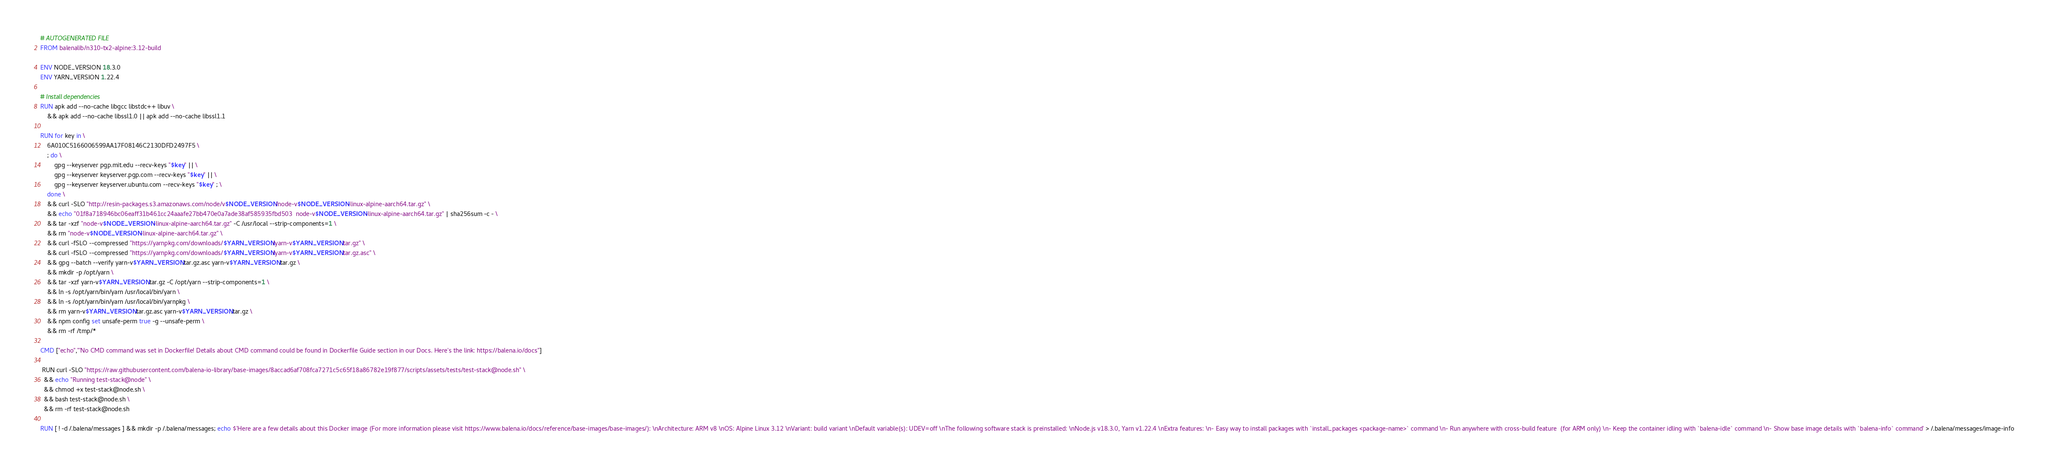Convert code to text. <code><loc_0><loc_0><loc_500><loc_500><_Dockerfile_># AUTOGENERATED FILE
FROM balenalib/n310-tx2-alpine:3.12-build

ENV NODE_VERSION 18.3.0
ENV YARN_VERSION 1.22.4

# Install dependencies
RUN apk add --no-cache libgcc libstdc++ libuv \
	&& apk add --no-cache libssl1.0 || apk add --no-cache libssl1.1

RUN for key in \
	6A010C5166006599AA17F08146C2130DFD2497F5 \
	; do \
		gpg --keyserver pgp.mit.edu --recv-keys "$key" || \
		gpg --keyserver keyserver.pgp.com --recv-keys "$key" || \
		gpg --keyserver keyserver.ubuntu.com --recv-keys "$key" ; \
	done \
	&& curl -SLO "http://resin-packages.s3.amazonaws.com/node/v$NODE_VERSION/node-v$NODE_VERSION-linux-alpine-aarch64.tar.gz" \
	&& echo "01f8a718946bc06eaff31b461cc24aaafe27bb470e0a7ade38af585935fbd503  node-v$NODE_VERSION-linux-alpine-aarch64.tar.gz" | sha256sum -c - \
	&& tar -xzf "node-v$NODE_VERSION-linux-alpine-aarch64.tar.gz" -C /usr/local --strip-components=1 \
	&& rm "node-v$NODE_VERSION-linux-alpine-aarch64.tar.gz" \
	&& curl -fSLO --compressed "https://yarnpkg.com/downloads/$YARN_VERSION/yarn-v$YARN_VERSION.tar.gz" \
	&& curl -fSLO --compressed "https://yarnpkg.com/downloads/$YARN_VERSION/yarn-v$YARN_VERSION.tar.gz.asc" \
	&& gpg --batch --verify yarn-v$YARN_VERSION.tar.gz.asc yarn-v$YARN_VERSION.tar.gz \
	&& mkdir -p /opt/yarn \
	&& tar -xzf yarn-v$YARN_VERSION.tar.gz -C /opt/yarn --strip-components=1 \
	&& ln -s /opt/yarn/bin/yarn /usr/local/bin/yarn \
	&& ln -s /opt/yarn/bin/yarn /usr/local/bin/yarnpkg \
	&& rm yarn-v$YARN_VERSION.tar.gz.asc yarn-v$YARN_VERSION.tar.gz \
	&& npm config set unsafe-perm true -g --unsafe-perm \
	&& rm -rf /tmp/*

CMD ["echo","'No CMD command was set in Dockerfile! Details about CMD command could be found in Dockerfile Guide section in our Docs. Here's the link: https://balena.io/docs"]

 RUN curl -SLO "https://raw.githubusercontent.com/balena-io-library/base-images/8accad6af708fca7271c5c65f18a86782e19f877/scripts/assets/tests/test-stack@node.sh" \
  && echo "Running test-stack@node" \
  && chmod +x test-stack@node.sh \
  && bash test-stack@node.sh \
  && rm -rf test-stack@node.sh 

RUN [ ! -d /.balena/messages ] && mkdir -p /.balena/messages; echo $'Here are a few details about this Docker image (For more information please visit https://www.balena.io/docs/reference/base-images/base-images/): \nArchitecture: ARM v8 \nOS: Alpine Linux 3.12 \nVariant: build variant \nDefault variable(s): UDEV=off \nThe following software stack is preinstalled: \nNode.js v18.3.0, Yarn v1.22.4 \nExtra features: \n- Easy way to install packages with `install_packages <package-name>` command \n- Run anywhere with cross-build feature  (for ARM only) \n- Keep the container idling with `balena-idle` command \n- Show base image details with `balena-info` command' > /.balena/messages/image-info</code> 